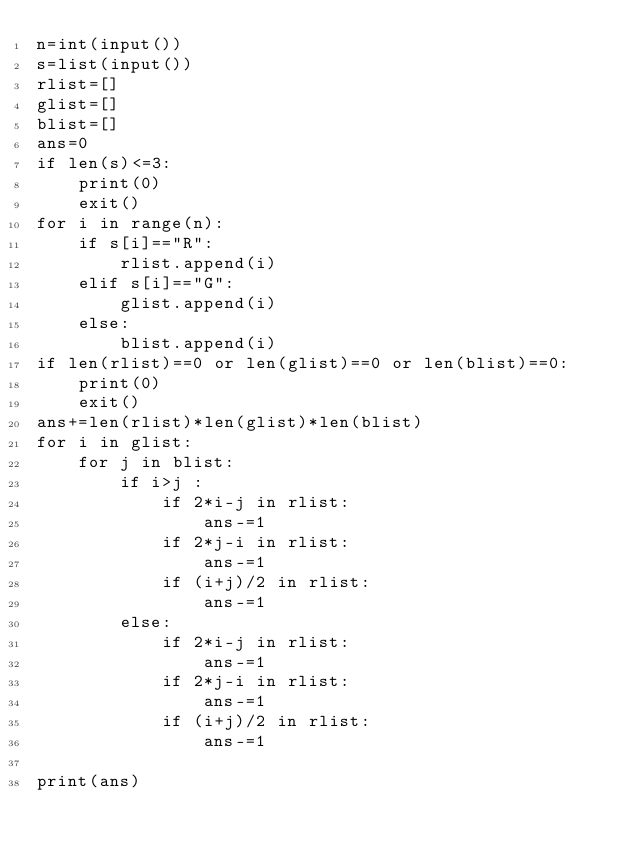Convert code to text. <code><loc_0><loc_0><loc_500><loc_500><_Python_>n=int(input())
s=list(input())
rlist=[]
glist=[]
blist=[]
ans=0
if len(s)<=3:
    print(0)
    exit()
for i in range(n):
    if s[i]=="R":
        rlist.append(i)
    elif s[i]=="G":
        glist.append(i)
    else:
        blist.append(i)
if len(rlist)==0 or len(glist)==0 or len(blist)==0:
    print(0)
    exit()
ans+=len(rlist)*len(glist)*len(blist)
for i in glist:
    for j in blist:
        if i>j :
            if 2*i-j in rlist:
                ans-=1
            if 2*j-i in rlist:
                ans-=1
            if (i+j)/2 in rlist:
                ans-=1
        else:
            if 2*i-j in rlist:
                ans-=1
            if 2*j-i in rlist:
                ans-=1
            if (i+j)/2 in rlist:
                ans-=1

print(ans)</code> 